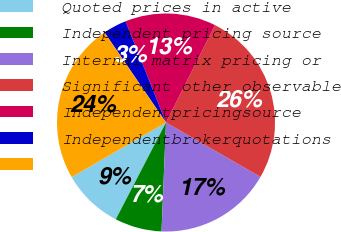<chart> <loc_0><loc_0><loc_500><loc_500><pie_chart><fcel>Quoted prices in active<fcel>Independent pricing source<fcel>Internal matrix pricing or<fcel>Significant other observable<fcel>Independentpricingsource<fcel>Independentbrokerquotations<fcel>Unnamed: 6<nl><fcel>9.04%<fcel>6.96%<fcel>17.34%<fcel>25.89%<fcel>13.48%<fcel>3.48%<fcel>23.81%<nl></chart> 